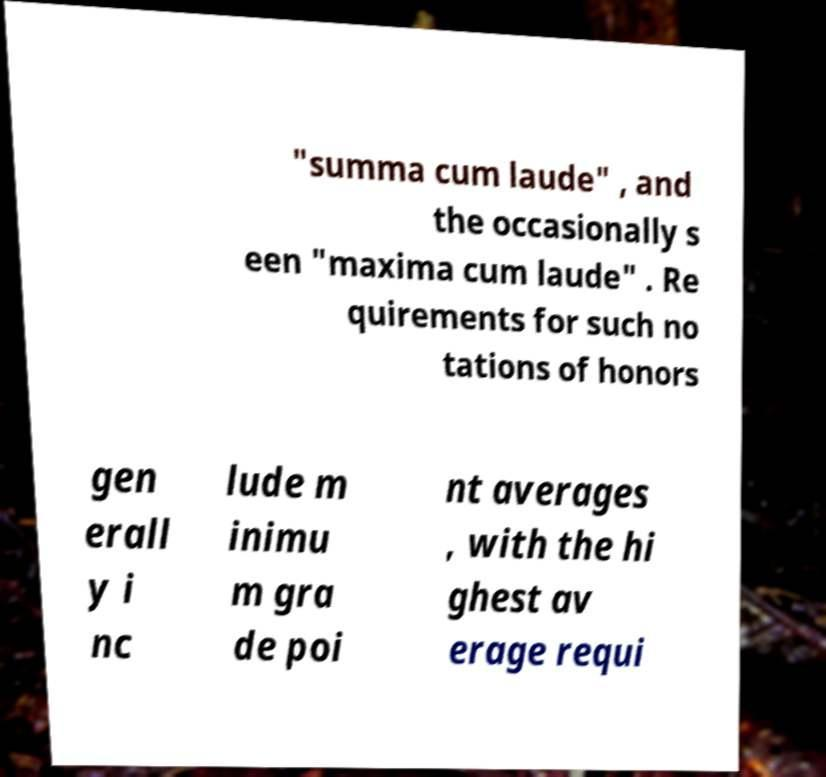Please identify and transcribe the text found in this image. "summa cum laude" , and the occasionally s een "maxima cum laude" . Re quirements for such no tations of honors gen erall y i nc lude m inimu m gra de poi nt averages , with the hi ghest av erage requi 